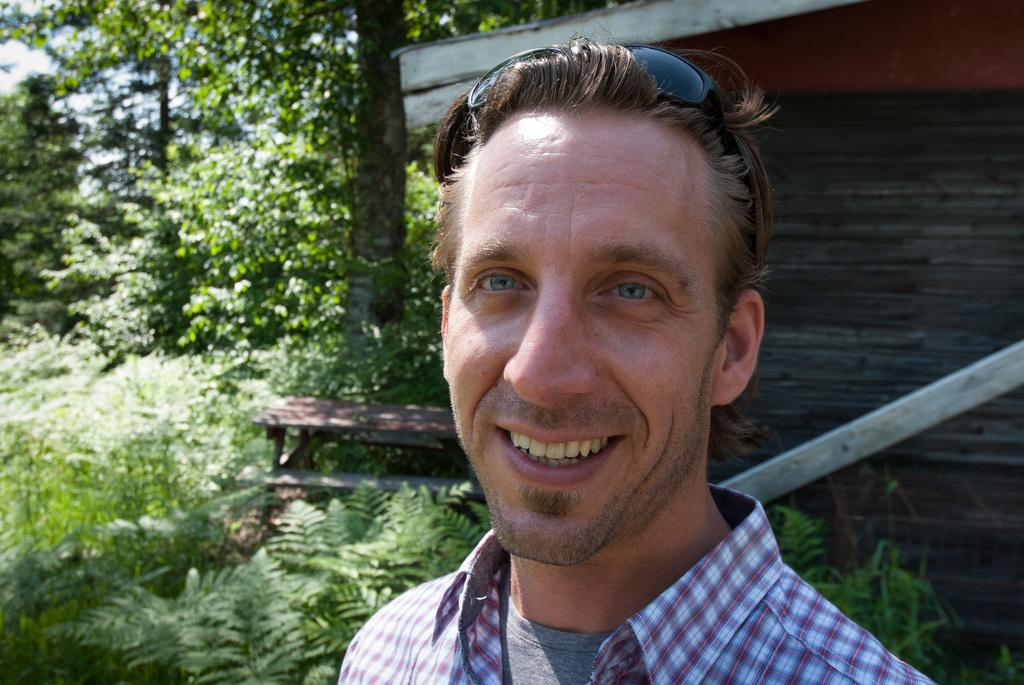Who or what is present in the image? There is a person in the image. What can be seen in the background of the image? There are trees, a wall, a bench, and the sky visible in the background of the image. What type of rhythm can be heard coming from the cactus in the image? There is no cactus present in the image, so it is not possible to determine what rhythm might be heard. 